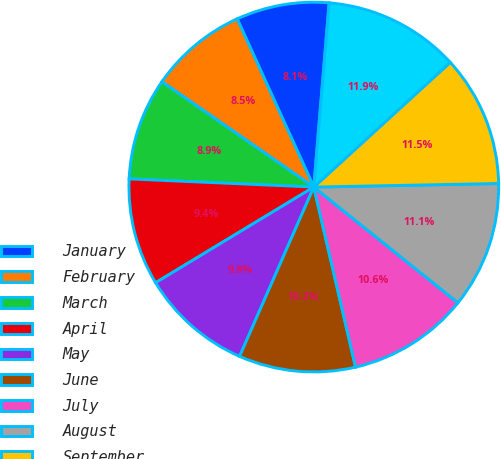Convert chart. <chart><loc_0><loc_0><loc_500><loc_500><pie_chart><fcel>January<fcel>February<fcel>March<fcel>April<fcel>May<fcel>June<fcel>July<fcel>August<fcel>September<fcel>October<nl><fcel>8.13%<fcel>8.54%<fcel>8.95%<fcel>9.36%<fcel>9.77%<fcel>10.2%<fcel>10.61%<fcel>11.07%<fcel>11.48%<fcel>11.89%<nl></chart> 